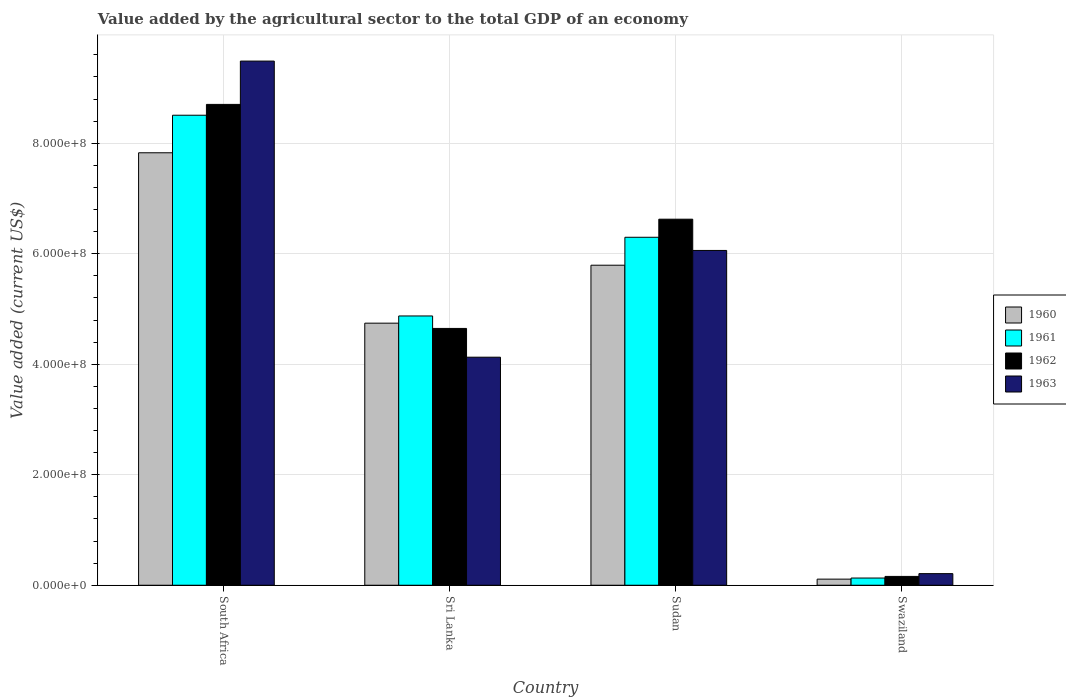How many different coloured bars are there?
Keep it short and to the point. 4. How many groups of bars are there?
Provide a short and direct response. 4. How many bars are there on the 1st tick from the right?
Offer a very short reply. 4. What is the label of the 2nd group of bars from the left?
Provide a succinct answer. Sri Lanka. What is the value added by the agricultural sector to the total GDP in 1960 in South Africa?
Provide a succinct answer. 7.83e+08. Across all countries, what is the maximum value added by the agricultural sector to the total GDP in 1961?
Make the answer very short. 8.51e+08. Across all countries, what is the minimum value added by the agricultural sector to the total GDP in 1961?
Give a very brief answer. 1.30e+07. In which country was the value added by the agricultural sector to the total GDP in 1961 maximum?
Your answer should be compact. South Africa. In which country was the value added by the agricultural sector to the total GDP in 1962 minimum?
Give a very brief answer. Swaziland. What is the total value added by the agricultural sector to the total GDP in 1960 in the graph?
Your answer should be very brief. 1.85e+09. What is the difference between the value added by the agricultural sector to the total GDP in 1960 in South Africa and that in Sudan?
Ensure brevity in your answer.  2.04e+08. What is the difference between the value added by the agricultural sector to the total GDP in 1960 in Sri Lanka and the value added by the agricultural sector to the total GDP in 1961 in South Africa?
Provide a short and direct response. -3.76e+08. What is the average value added by the agricultural sector to the total GDP in 1960 per country?
Provide a succinct answer. 4.62e+08. What is the difference between the value added by the agricultural sector to the total GDP of/in 1960 and value added by the agricultural sector to the total GDP of/in 1962 in Swaziland?
Provide a succinct answer. -4.90e+06. In how many countries, is the value added by the agricultural sector to the total GDP in 1960 greater than 760000000 US$?
Offer a terse response. 1. What is the ratio of the value added by the agricultural sector to the total GDP in 1961 in Sudan to that in Swaziland?
Provide a short and direct response. 48.37. Is the value added by the agricultural sector to the total GDP in 1961 in South Africa less than that in Sudan?
Offer a very short reply. No. Is the difference between the value added by the agricultural sector to the total GDP in 1960 in Sri Lanka and Sudan greater than the difference between the value added by the agricultural sector to the total GDP in 1962 in Sri Lanka and Sudan?
Provide a short and direct response. Yes. What is the difference between the highest and the second highest value added by the agricultural sector to the total GDP in 1960?
Give a very brief answer. 1.05e+08. What is the difference between the highest and the lowest value added by the agricultural sector to the total GDP in 1960?
Your response must be concise. 7.72e+08. Is the sum of the value added by the agricultural sector to the total GDP in 1961 in Sudan and Swaziland greater than the maximum value added by the agricultural sector to the total GDP in 1960 across all countries?
Your response must be concise. No. Is it the case that in every country, the sum of the value added by the agricultural sector to the total GDP in 1963 and value added by the agricultural sector to the total GDP in 1961 is greater than the sum of value added by the agricultural sector to the total GDP in 1962 and value added by the agricultural sector to the total GDP in 1960?
Keep it short and to the point. No. What does the 3rd bar from the left in Sri Lanka represents?
Your answer should be very brief. 1962. Does the graph contain any zero values?
Keep it short and to the point. No. Where does the legend appear in the graph?
Offer a very short reply. Center right. How many legend labels are there?
Offer a very short reply. 4. What is the title of the graph?
Provide a succinct answer. Value added by the agricultural sector to the total GDP of an economy. What is the label or title of the Y-axis?
Give a very brief answer. Value added (current US$). What is the Value added (current US$) in 1960 in South Africa?
Provide a short and direct response. 7.83e+08. What is the Value added (current US$) in 1961 in South Africa?
Give a very brief answer. 8.51e+08. What is the Value added (current US$) of 1962 in South Africa?
Your answer should be very brief. 8.70e+08. What is the Value added (current US$) of 1963 in South Africa?
Your answer should be compact. 9.49e+08. What is the Value added (current US$) in 1960 in Sri Lanka?
Provide a succinct answer. 4.74e+08. What is the Value added (current US$) in 1961 in Sri Lanka?
Give a very brief answer. 4.87e+08. What is the Value added (current US$) in 1962 in Sri Lanka?
Offer a very short reply. 4.65e+08. What is the Value added (current US$) in 1963 in Sri Lanka?
Make the answer very short. 4.13e+08. What is the Value added (current US$) in 1960 in Sudan?
Provide a succinct answer. 5.79e+08. What is the Value added (current US$) of 1961 in Sudan?
Ensure brevity in your answer.  6.30e+08. What is the Value added (current US$) of 1962 in Sudan?
Make the answer very short. 6.63e+08. What is the Value added (current US$) in 1963 in Sudan?
Your answer should be compact. 6.06e+08. What is the Value added (current US$) of 1960 in Swaziland?
Give a very brief answer. 1.11e+07. What is the Value added (current US$) of 1961 in Swaziland?
Your answer should be compact. 1.30e+07. What is the Value added (current US$) of 1962 in Swaziland?
Give a very brief answer. 1.60e+07. What is the Value added (current US$) in 1963 in Swaziland?
Provide a short and direct response. 2.10e+07. Across all countries, what is the maximum Value added (current US$) in 1960?
Give a very brief answer. 7.83e+08. Across all countries, what is the maximum Value added (current US$) of 1961?
Offer a terse response. 8.51e+08. Across all countries, what is the maximum Value added (current US$) in 1962?
Ensure brevity in your answer.  8.70e+08. Across all countries, what is the maximum Value added (current US$) in 1963?
Your answer should be very brief. 9.49e+08. Across all countries, what is the minimum Value added (current US$) in 1960?
Provide a short and direct response. 1.11e+07. Across all countries, what is the minimum Value added (current US$) in 1961?
Offer a very short reply. 1.30e+07. Across all countries, what is the minimum Value added (current US$) in 1962?
Ensure brevity in your answer.  1.60e+07. Across all countries, what is the minimum Value added (current US$) in 1963?
Give a very brief answer. 2.10e+07. What is the total Value added (current US$) in 1960 in the graph?
Your answer should be compact. 1.85e+09. What is the total Value added (current US$) in 1961 in the graph?
Your answer should be compact. 1.98e+09. What is the total Value added (current US$) of 1962 in the graph?
Ensure brevity in your answer.  2.01e+09. What is the total Value added (current US$) of 1963 in the graph?
Offer a very short reply. 1.99e+09. What is the difference between the Value added (current US$) of 1960 in South Africa and that in Sri Lanka?
Keep it short and to the point. 3.08e+08. What is the difference between the Value added (current US$) in 1961 in South Africa and that in Sri Lanka?
Provide a short and direct response. 3.63e+08. What is the difference between the Value added (current US$) in 1962 in South Africa and that in Sri Lanka?
Keep it short and to the point. 4.06e+08. What is the difference between the Value added (current US$) of 1963 in South Africa and that in Sri Lanka?
Provide a succinct answer. 5.36e+08. What is the difference between the Value added (current US$) in 1960 in South Africa and that in Sudan?
Provide a short and direct response. 2.04e+08. What is the difference between the Value added (current US$) in 1961 in South Africa and that in Sudan?
Your answer should be compact. 2.21e+08. What is the difference between the Value added (current US$) in 1962 in South Africa and that in Sudan?
Make the answer very short. 2.08e+08. What is the difference between the Value added (current US$) of 1963 in South Africa and that in Sudan?
Make the answer very short. 3.43e+08. What is the difference between the Value added (current US$) of 1960 in South Africa and that in Swaziland?
Keep it short and to the point. 7.72e+08. What is the difference between the Value added (current US$) of 1961 in South Africa and that in Swaziland?
Keep it short and to the point. 8.38e+08. What is the difference between the Value added (current US$) in 1962 in South Africa and that in Swaziland?
Ensure brevity in your answer.  8.54e+08. What is the difference between the Value added (current US$) in 1963 in South Africa and that in Swaziland?
Provide a short and direct response. 9.28e+08. What is the difference between the Value added (current US$) in 1960 in Sri Lanka and that in Sudan?
Ensure brevity in your answer.  -1.05e+08. What is the difference between the Value added (current US$) in 1961 in Sri Lanka and that in Sudan?
Provide a succinct answer. -1.42e+08. What is the difference between the Value added (current US$) in 1962 in Sri Lanka and that in Sudan?
Provide a short and direct response. -1.98e+08. What is the difference between the Value added (current US$) in 1963 in Sri Lanka and that in Sudan?
Make the answer very short. -1.93e+08. What is the difference between the Value added (current US$) of 1960 in Sri Lanka and that in Swaziland?
Ensure brevity in your answer.  4.63e+08. What is the difference between the Value added (current US$) of 1961 in Sri Lanka and that in Swaziland?
Provide a short and direct response. 4.74e+08. What is the difference between the Value added (current US$) in 1962 in Sri Lanka and that in Swaziland?
Ensure brevity in your answer.  4.49e+08. What is the difference between the Value added (current US$) of 1963 in Sri Lanka and that in Swaziland?
Provide a succinct answer. 3.92e+08. What is the difference between the Value added (current US$) in 1960 in Sudan and that in Swaziland?
Your answer should be very brief. 5.68e+08. What is the difference between the Value added (current US$) of 1961 in Sudan and that in Swaziland?
Your answer should be very brief. 6.17e+08. What is the difference between the Value added (current US$) of 1962 in Sudan and that in Swaziland?
Give a very brief answer. 6.47e+08. What is the difference between the Value added (current US$) of 1963 in Sudan and that in Swaziland?
Your response must be concise. 5.85e+08. What is the difference between the Value added (current US$) in 1960 in South Africa and the Value added (current US$) in 1961 in Sri Lanka?
Your response must be concise. 2.95e+08. What is the difference between the Value added (current US$) of 1960 in South Africa and the Value added (current US$) of 1962 in Sri Lanka?
Keep it short and to the point. 3.18e+08. What is the difference between the Value added (current US$) in 1960 in South Africa and the Value added (current US$) in 1963 in Sri Lanka?
Your answer should be very brief. 3.70e+08. What is the difference between the Value added (current US$) of 1961 in South Africa and the Value added (current US$) of 1962 in Sri Lanka?
Your answer should be very brief. 3.86e+08. What is the difference between the Value added (current US$) in 1961 in South Africa and the Value added (current US$) in 1963 in Sri Lanka?
Provide a succinct answer. 4.38e+08. What is the difference between the Value added (current US$) in 1962 in South Africa and the Value added (current US$) in 1963 in Sri Lanka?
Your response must be concise. 4.58e+08. What is the difference between the Value added (current US$) of 1960 in South Africa and the Value added (current US$) of 1961 in Sudan?
Make the answer very short. 1.53e+08. What is the difference between the Value added (current US$) of 1960 in South Africa and the Value added (current US$) of 1962 in Sudan?
Your answer should be very brief. 1.20e+08. What is the difference between the Value added (current US$) in 1960 in South Africa and the Value added (current US$) in 1963 in Sudan?
Your answer should be compact. 1.77e+08. What is the difference between the Value added (current US$) in 1961 in South Africa and the Value added (current US$) in 1962 in Sudan?
Provide a succinct answer. 1.88e+08. What is the difference between the Value added (current US$) in 1961 in South Africa and the Value added (current US$) in 1963 in Sudan?
Offer a very short reply. 2.45e+08. What is the difference between the Value added (current US$) in 1962 in South Africa and the Value added (current US$) in 1963 in Sudan?
Keep it short and to the point. 2.64e+08. What is the difference between the Value added (current US$) of 1960 in South Africa and the Value added (current US$) of 1961 in Swaziland?
Make the answer very short. 7.70e+08. What is the difference between the Value added (current US$) in 1960 in South Africa and the Value added (current US$) in 1962 in Swaziland?
Offer a terse response. 7.67e+08. What is the difference between the Value added (current US$) of 1960 in South Africa and the Value added (current US$) of 1963 in Swaziland?
Your answer should be compact. 7.62e+08. What is the difference between the Value added (current US$) of 1961 in South Africa and the Value added (current US$) of 1962 in Swaziland?
Your answer should be very brief. 8.35e+08. What is the difference between the Value added (current US$) in 1961 in South Africa and the Value added (current US$) in 1963 in Swaziland?
Offer a very short reply. 8.30e+08. What is the difference between the Value added (current US$) of 1962 in South Africa and the Value added (current US$) of 1963 in Swaziland?
Your answer should be compact. 8.49e+08. What is the difference between the Value added (current US$) in 1960 in Sri Lanka and the Value added (current US$) in 1961 in Sudan?
Offer a very short reply. -1.55e+08. What is the difference between the Value added (current US$) in 1960 in Sri Lanka and the Value added (current US$) in 1962 in Sudan?
Provide a succinct answer. -1.88e+08. What is the difference between the Value added (current US$) of 1960 in Sri Lanka and the Value added (current US$) of 1963 in Sudan?
Keep it short and to the point. -1.32e+08. What is the difference between the Value added (current US$) in 1961 in Sri Lanka and the Value added (current US$) in 1962 in Sudan?
Ensure brevity in your answer.  -1.75e+08. What is the difference between the Value added (current US$) in 1961 in Sri Lanka and the Value added (current US$) in 1963 in Sudan?
Your answer should be very brief. -1.19e+08. What is the difference between the Value added (current US$) in 1962 in Sri Lanka and the Value added (current US$) in 1963 in Sudan?
Your answer should be compact. -1.41e+08. What is the difference between the Value added (current US$) in 1960 in Sri Lanka and the Value added (current US$) in 1961 in Swaziland?
Give a very brief answer. 4.61e+08. What is the difference between the Value added (current US$) of 1960 in Sri Lanka and the Value added (current US$) of 1962 in Swaziland?
Give a very brief answer. 4.58e+08. What is the difference between the Value added (current US$) in 1960 in Sri Lanka and the Value added (current US$) in 1963 in Swaziland?
Your response must be concise. 4.53e+08. What is the difference between the Value added (current US$) in 1961 in Sri Lanka and the Value added (current US$) in 1962 in Swaziland?
Keep it short and to the point. 4.71e+08. What is the difference between the Value added (current US$) in 1961 in Sri Lanka and the Value added (current US$) in 1963 in Swaziland?
Your answer should be compact. 4.66e+08. What is the difference between the Value added (current US$) of 1962 in Sri Lanka and the Value added (current US$) of 1963 in Swaziland?
Keep it short and to the point. 4.44e+08. What is the difference between the Value added (current US$) in 1960 in Sudan and the Value added (current US$) in 1961 in Swaziland?
Your response must be concise. 5.66e+08. What is the difference between the Value added (current US$) in 1960 in Sudan and the Value added (current US$) in 1962 in Swaziland?
Your response must be concise. 5.63e+08. What is the difference between the Value added (current US$) of 1960 in Sudan and the Value added (current US$) of 1963 in Swaziland?
Offer a very short reply. 5.58e+08. What is the difference between the Value added (current US$) in 1961 in Sudan and the Value added (current US$) in 1962 in Swaziland?
Ensure brevity in your answer.  6.14e+08. What is the difference between the Value added (current US$) of 1961 in Sudan and the Value added (current US$) of 1963 in Swaziland?
Make the answer very short. 6.09e+08. What is the difference between the Value added (current US$) of 1962 in Sudan and the Value added (current US$) of 1963 in Swaziland?
Your response must be concise. 6.42e+08. What is the average Value added (current US$) in 1960 per country?
Your response must be concise. 4.62e+08. What is the average Value added (current US$) of 1961 per country?
Offer a very short reply. 4.95e+08. What is the average Value added (current US$) in 1962 per country?
Your answer should be compact. 5.03e+08. What is the average Value added (current US$) of 1963 per country?
Your answer should be very brief. 4.97e+08. What is the difference between the Value added (current US$) in 1960 and Value added (current US$) in 1961 in South Africa?
Give a very brief answer. -6.80e+07. What is the difference between the Value added (current US$) of 1960 and Value added (current US$) of 1962 in South Africa?
Give a very brief answer. -8.76e+07. What is the difference between the Value added (current US$) of 1960 and Value added (current US$) of 1963 in South Africa?
Provide a short and direct response. -1.66e+08. What is the difference between the Value added (current US$) of 1961 and Value added (current US$) of 1962 in South Africa?
Your response must be concise. -1.96e+07. What is the difference between the Value added (current US$) of 1961 and Value added (current US$) of 1963 in South Africa?
Provide a succinct answer. -9.80e+07. What is the difference between the Value added (current US$) in 1962 and Value added (current US$) in 1963 in South Africa?
Provide a short and direct response. -7.84e+07. What is the difference between the Value added (current US$) of 1960 and Value added (current US$) of 1961 in Sri Lanka?
Provide a succinct answer. -1.30e+07. What is the difference between the Value added (current US$) of 1960 and Value added (current US$) of 1962 in Sri Lanka?
Your answer should be compact. 9.55e+06. What is the difference between the Value added (current US$) of 1960 and Value added (current US$) of 1963 in Sri Lanka?
Give a very brief answer. 6.16e+07. What is the difference between the Value added (current US$) of 1961 and Value added (current US$) of 1962 in Sri Lanka?
Your answer should be very brief. 2.26e+07. What is the difference between the Value added (current US$) in 1961 and Value added (current US$) in 1963 in Sri Lanka?
Your answer should be very brief. 7.46e+07. What is the difference between the Value added (current US$) of 1962 and Value added (current US$) of 1963 in Sri Lanka?
Your answer should be very brief. 5.20e+07. What is the difference between the Value added (current US$) of 1960 and Value added (current US$) of 1961 in Sudan?
Provide a succinct answer. -5.05e+07. What is the difference between the Value added (current US$) in 1960 and Value added (current US$) in 1962 in Sudan?
Offer a terse response. -8.33e+07. What is the difference between the Value added (current US$) of 1960 and Value added (current US$) of 1963 in Sudan?
Give a very brief answer. -2.67e+07. What is the difference between the Value added (current US$) in 1961 and Value added (current US$) in 1962 in Sudan?
Provide a short and direct response. -3.27e+07. What is the difference between the Value added (current US$) of 1961 and Value added (current US$) of 1963 in Sudan?
Provide a succinct answer. 2.38e+07. What is the difference between the Value added (current US$) in 1962 and Value added (current US$) in 1963 in Sudan?
Offer a terse response. 5.66e+07. What is the difference between the Value added (current US$) in 1960 and Value added (current US$) in 1961 in Swaziland?
Your response must be concise. -1.96e+06. What is the difference between the Value added (current US$) of 1960 and Value added (current US$) of 1962 in Swaziland?
Provide a short and direct response. -4.90e+06. What is the difference between the Value added (current US$) in 1960 and Value added (current US$) in 1963 in Swaziland?
Offer a very short reply. -9.94e+06. What is the difference between the Value added (current US$) in 1961 and Value added (current US$) in 1962 in Swaziland?
Provide a succinct answer. -2.94e+06. What is the difference between the Value added (current US$) in 1961 and Value added (current US$) in 1963 in Swaziland?
Provide a succinct answer. -7.98e+06. What is the difference between the Value added (current US$) in 1962 and Value added (current US$) in 1963 in Swaziland?
Offer a terse response. -5.04e+06. What is the ratio of the Value added (current US$) of 1960 in South Africa to that in Sri Lanka?
Provide a short and direct response. 1.65. What is the ratio of the Value added (current US$) in 1961 in South Africa to that in Sri Lanka?
Provide a short and direct response. 1.75. What is the ratio of the Value added (current US$) in 1962 in South Africa to that in Sri Lanka?
Offer a very short reply. 1.87. What is the ratio of the Value added (current US$) in 1963 in South Africa to that in Sri Lanka?
Keep it short and to the point. 2.3. What is the ratio of the Value added (current US$) in 1960 in South Africa to that in Sudan?
Provide a succinct answer. 1.35. What is the ratio of the Value added (current US$) of 1961 in South Africa to that in Sudan?
Make the answer very short. 1.35. What is the ratio of the Value added (current US$) of 1962 in South Africa to that in Sudan?
Offer a terse response. 1.31. What is the ratio of the Value added (current US$) of 1963 in South Africa to that in Sudan?
Your response must be concise. 1.57. What is the ratio of the Value added (current US$) in 1960 in South Africa to that in Swaziland?
Your answer should be very brief. 70.77. What is the ratio of the Value added (current US$) in 1961 in South Africa to that in Swaziland?
Offer a very short reply. 65.34. What is the ratio of the Value added (current US$) in 1962 in South Africa to that in Swaziland?
Provide a succinct answer. 54.53. What is the ratio of the Value added (current US$) in 1963 in South Africa to that in Swaziland?
Your answer should be very brief. 45.18. What is the ratio of the Value added (current US$) of 1960 in Sri Lanka to that in Sudan?
Provide a succinct answer. 0.82. What is the ratio of the Value added (current US$) in 1961 in Sri Lanka to that in Sudan?
Provide a short and direct response. 0.77. What is the ratio of the Value added (current US$) in 1962 in Sri Lanka to that in Sudan?
Offer a terse response. 0.7. What is the ratio of the Value added (current US$) of 1963 in Sri Lanka to that in Sudan?
Give a very brief answer. 0.68. What is the ratio of the Value added (current US$) of 1960 in Sri Lanka to that in Swaziland?
Your answer should be very brief. 42.89. What is the ratio of the Value added (current US$) in 1961 in Sri Lanka to that in Swaziland?
Your response must be concise. 37.43. What is the ratio of the Value added (current US$) in 1962 in Sri Lanka to that in Swaziland?
Offer a very short reply. 29.12. What is the ratio of the Value added (current US$) in 1963 in Sri Lanka to that in Swaziland?
Keep it short and to the point. 19.66. What is the ratio of the Value added (current US$) in 1960 in Sudan to that in Swaziland?
Your answer should be very brief. 52.37. What is the ratio of the Value added (current US$) in 1961 in Sudan to that in Swaziland?
Offer a terse response. 48.37. What is the ratio of the Value added (current US$) of 1962 in Sudan to that in Swaziland?
Your answer should be compact. 41.51. What is the ratio of the Value added (current US$) of 1963 in Sudan to that in Swaziland?
Keep it short and to the point. 28.86. What is the difference between the highest and the second highest Value added (current US$) of 1960?
Offer a very short reply. 2.04e+08. What is the difference between the highest and the second highest Value added (current US$) of 1961?
Offer a terse response. 2.21e+08. What is the difference between the highest and the second highest Value added (current US$) of 1962?
Offer a terse response. 2.08e+08. What is the difference between the highest and the second highest Value added (current US$) of 1963?
Your answer should be compact. 3.43e+08. What is the difference between the highest and the lowest Value added (current US$) in 1960?
Ensure brevity in your answer.  7.72e+08. What is the difference between the highest and the lowest Value added (current US$) in 1961?
Give a very brief answer. 8.38e+08. What is the difference between the highest and the lowest Value added (current US$) in 1962?
Ensure brevity in your answer.  8.54e+08. What is the difference between the highest and the lowest Value added (current US$) of 1963?
Your response must be concise. 9.28e+08. 